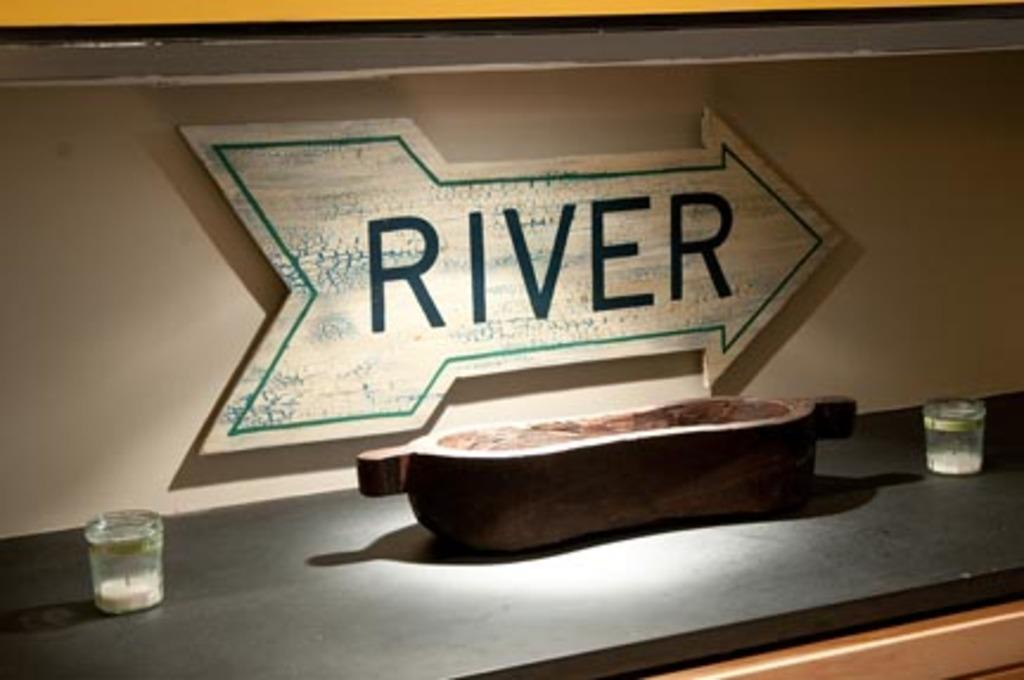Provide a one-sentence caption for the provided image. A kitchen countertop with a bowl, two candles, and an arrow sign with the word "river" painted on it. 